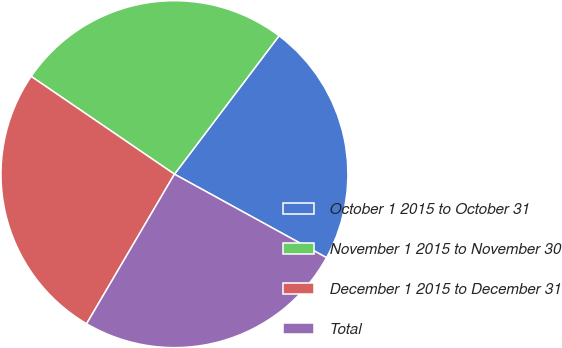Convert chart to OTSL. <chart><loc_0><loc_0><loc_500><loc_500><pie_chart><fcel>October 1 2015 to October 31<fcel>November 1 2015 to November 30<fcel>December 1 2015 to December 31<fcel>Total<nl><fcel>22.69%<fcel>25.77%<fcel>26.08%<fcel>25.46%<nl></chart> 